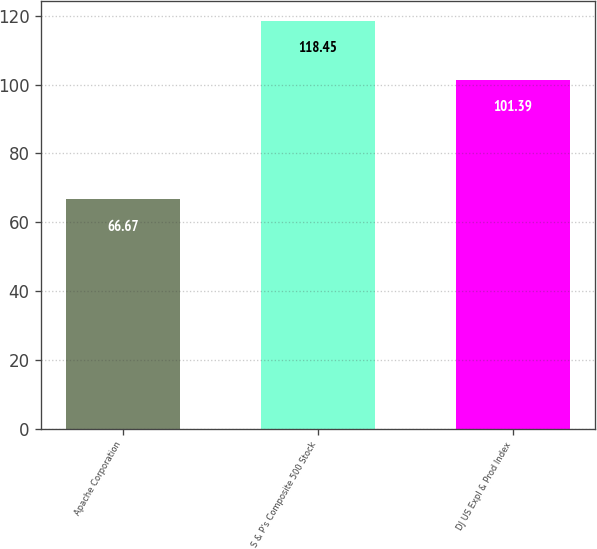Convert chart to OTSL. <chart><loc_0><loc_0><loc_500><loc_500><bar_chart><fcel>Apache Corporation<fcel>S & P's Composite 500 Stock<fcel>DJ US Expl & Prod Index<nl><fcel>66.67<fcel>118.45<fcel>101.39<nl></chart> 